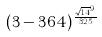Convert formula to latex. <formula><loc_0><loc_0><loc_500><loc_500>( 3 - 3 6 4 ) ^ { \frac { \sqrt { 1 4 } ^ { 9 } } { 3 2 5 } }</formula> 